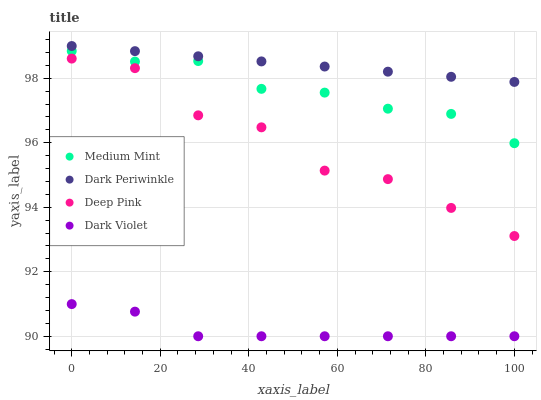Does Dark Violet have the minimum area under the curve?
Answer yes or no. Yes. Does Dark Periwinkle have the maximum area under the curve?
Answer yes or no. Yes. Does Deep Pink have the minimum area under the curve?
Answer yes or no. No. Does Deep Pink have the maximum area under the curve?
Answer yes or no. No. Is Dark Periwinkle the smoothest?
Answer yes or no. Yes. Is Deep Pink the roughest?
Answer yes or no. Yes. Is Deep Pink the smoothest?
Answer yes or no. No. Is Dark Periwinkle the roughest?
Answer yes or no. No. Does Dark Violet have the lowest value?
Answer yes or no. Yes. Does Deep Pink have the lowest value?
Answer yes or no. No. Does Dark Periwinkle have the highest value?
Answer yes or no. Yes. Does Deep Pink have the highest value?
Answer yes or no. No. Is Deep Pink less than Dark Periwinkle?
Answer yes or no. Yes. Is Medium Mint greater than Dark Violet?
Answer yes or no. Yes. Does Deep Pink intersect Dark Periwinkle?
Answer yes or no. No. 